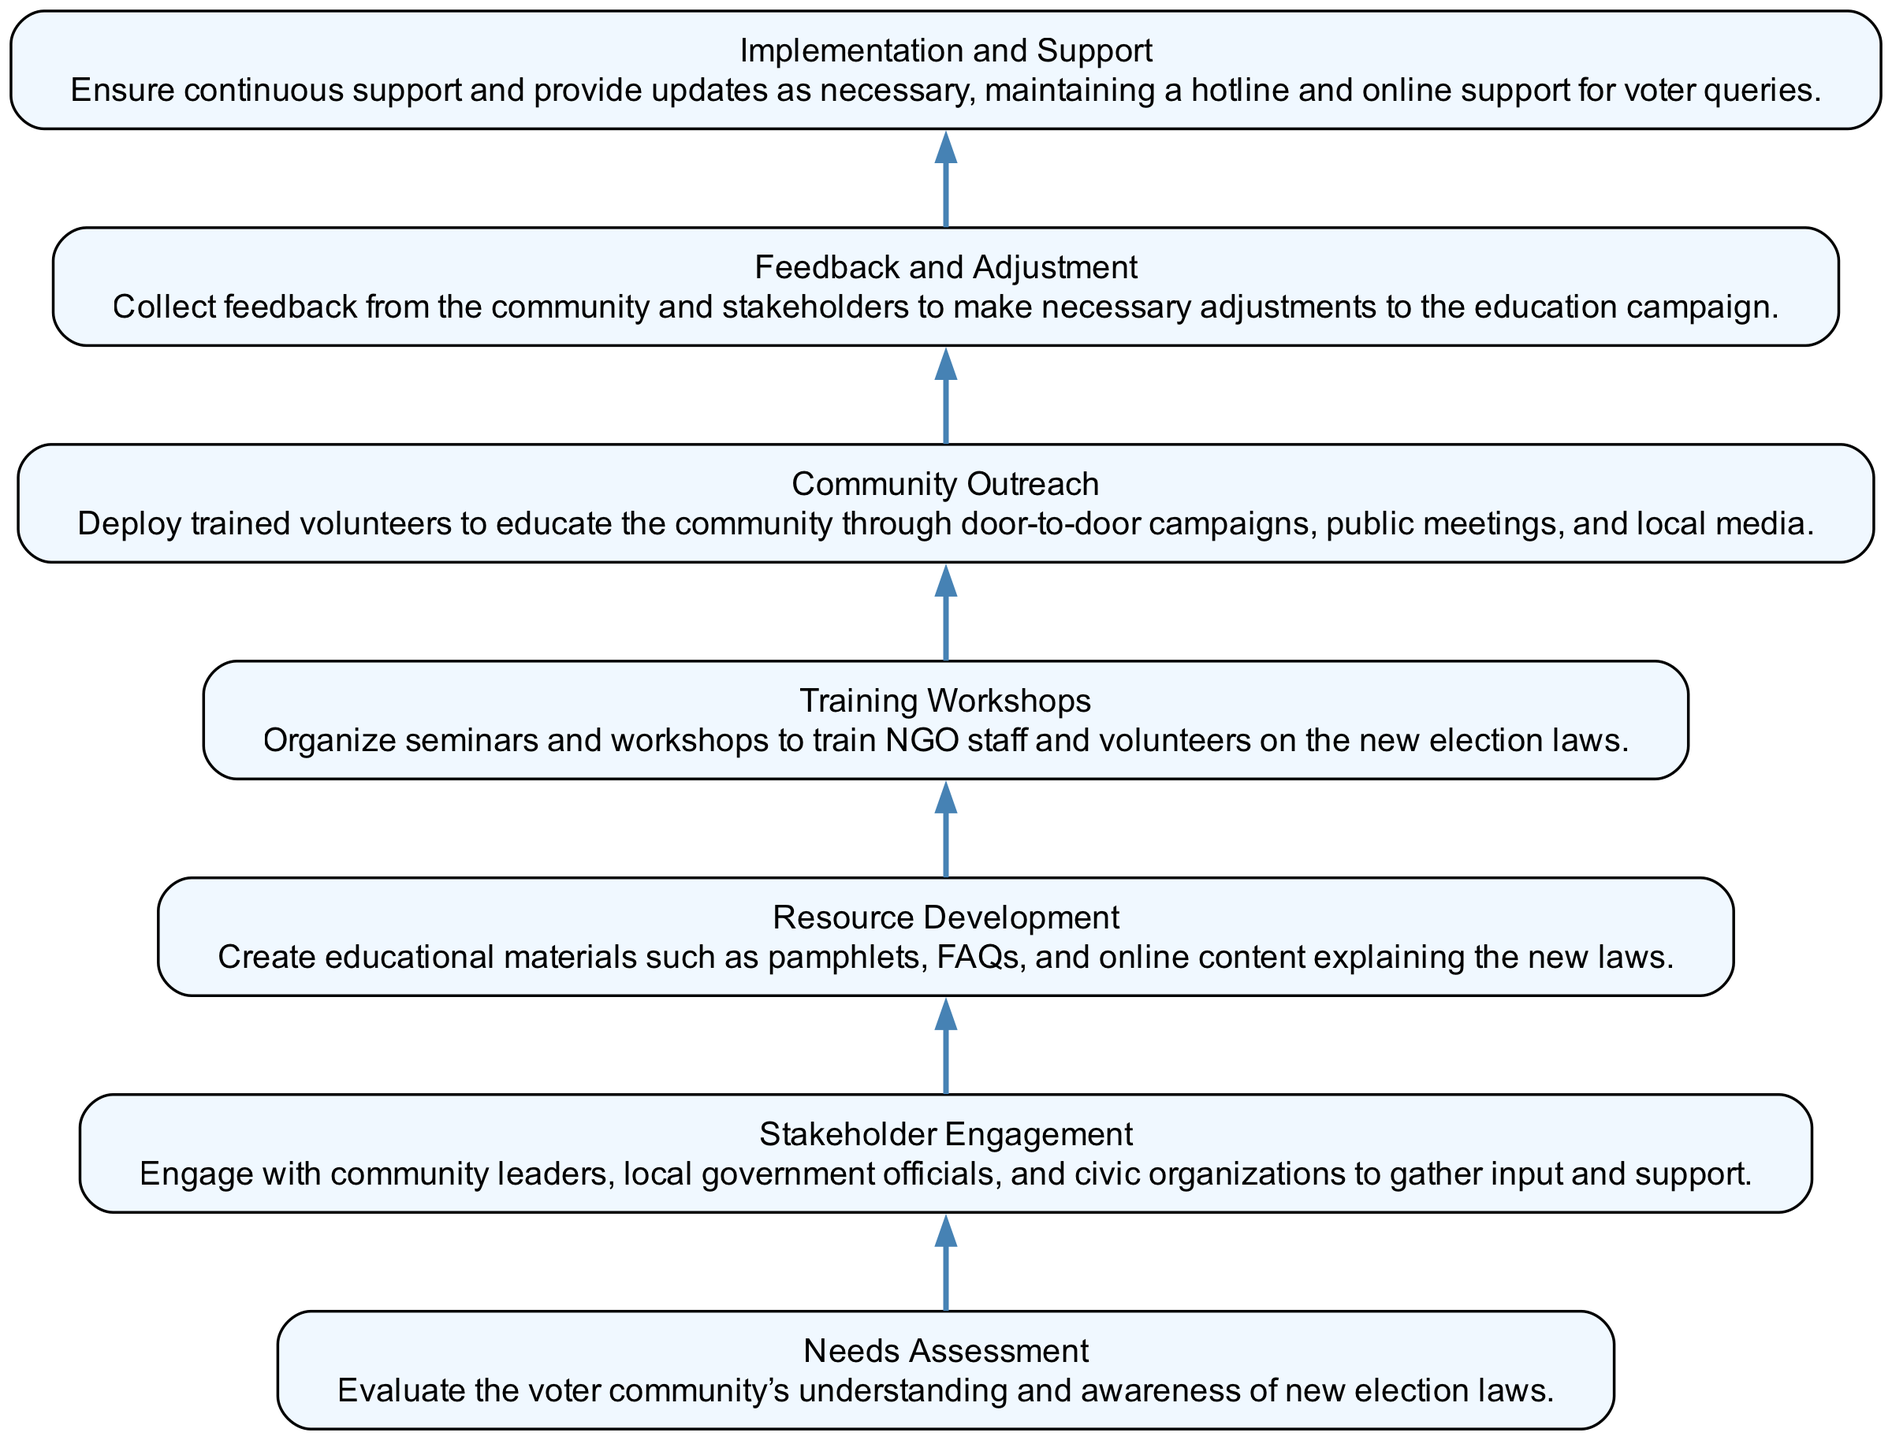What is the title of the bottom step? The diagram specifies the bottom step as "Needs Assessment." This is the first node in the flow, indicating the starting point of the process.
Answer: Needs Assessment How many total steps are in the diagram? By counting the number of defined steps in the flow, we see there are 6 distinct actions or titles mentioned. Each of these represents a step in the process.
Answer: 6 What step comes directly after "Stakeholder Engagement"? Looking at the diagram, "Resource Development" is located above "Stakeholder Engagement," indicating it follows that step directly in the flow.
Answer: Resource Development Which step involves community leader engagement? The node labeled "Stakeholder Engagement" specifically mentions engaging with community leaders as part of its description, focusing on gathering input and support.
Answer: Stakeholder Engagement What is the last step in the process? The final step at the top of the flow diagram is "Feedback and Adjustment," which signifies the culmination of the educational process that involves assessing feedback from the community.
Answer: Feedback and Adjustment Which step requires educational materials to be created? "Resource Development" is the step where it mentions creating educational materials like pamphlets and FAQs, making it central for distributing information about new election laws.
Answer: Resource Development Which action comes before "Community Outreach"? Before "Community Outreach," the step is "Training Workshops." This sequence shows the necessity of training before reaching out to educate the community.
Answer: Training Workshops What is the main focus of "Implementation and Support"? The main focus is to ensure continuous support and provide updates to the community, which is essential for maintaining effective voter education and response systems.
Answer: Continuous support Which step includes door-to-door campaigns? "Community Outreach" specifically mentions deploying trained volunteers for door-to-door campaigns as part of its outreach strategies.
Answer: Community Outreach 